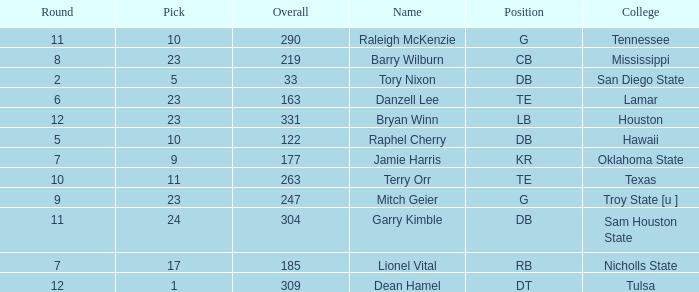How many Picks have a College of hawaii, and an Overall smaller than 122? 0.0. 